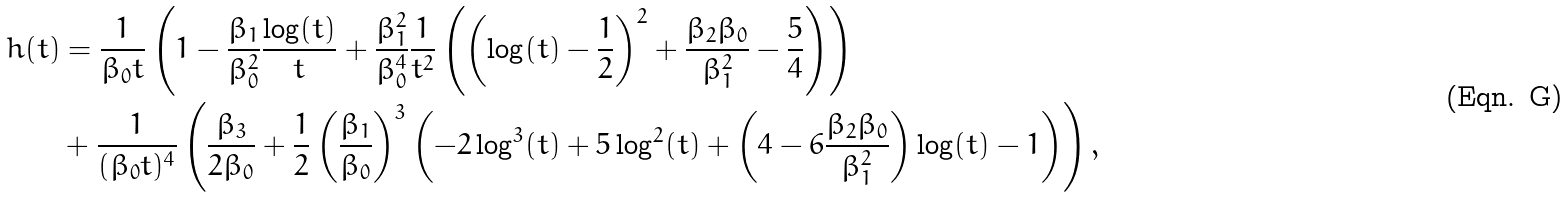Convert formula to latex. <formula><loc_0><loc_0><loc_500><loc_500>h ( t ) & = \frac { 1 } { \beta _ { 0 } t } \left ( 1 - \frac { \beta _ { 1 } } { \beta _ { 0 } ^ { 2 } } \frac { \log ( t ) } { t } + \frac { \beta _ { 1 } ^ { 2 } } { \beta _ { 0 } ^ { 4 } } \frac { 1 } { t ^ { 2 } } \left ( \left ( \log ( t ) - \frac { 1 } { 2 } \right ) ^ { 2 } + \frac { \beta _ { 2 } \beta _ { 0 } } { \beta _ { 1 } ^ { 2 } } - \frac { 5 } { 4 } \right ) \right ) \\ & + \frac { 1 } { ( \beta _ { 0 } t ) ^ { 4 } } \left ( \frac { \beta _ { 3 } } { 2 \beta _ { 0 } } + \frac { 1 } { 2 } \left ( \frac { \beta _ { 1 } } { \beta _ { 0 } } \right ) ^ { 3 } \left ( - 2 \log ^ { 3 } ( t ) + 5 \log ^ { 2 } ( t ) + \left ( 4 - 6 \frac { \beta _ { 2 } \beta _ { 0 } } { \beta _ { 1 } ^ { 2 } } \right ) \log ( t ) - 1 \right ) \right ) ,</formula> 